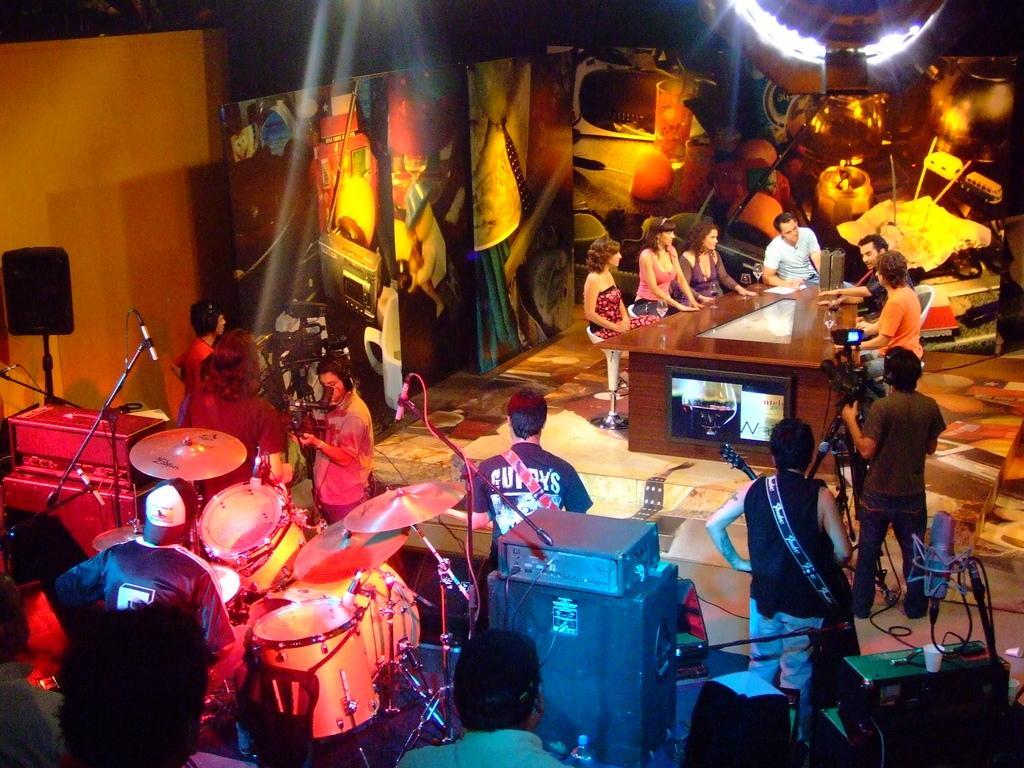In one or two sentences, can you explain what this image depicts? As we can see in the image there are banners, musical drums, mics and few people standing and sitting on chairs and the man who is standing here is holding camera and in front of them there is a table. 